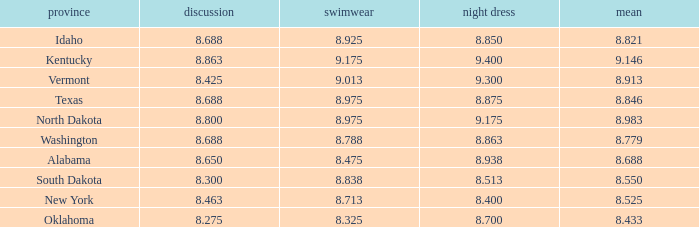What is the lowest evening score of the contestant with an evening gown less than 8.938, from Texas, and with an average less than 8.846 has? None. 